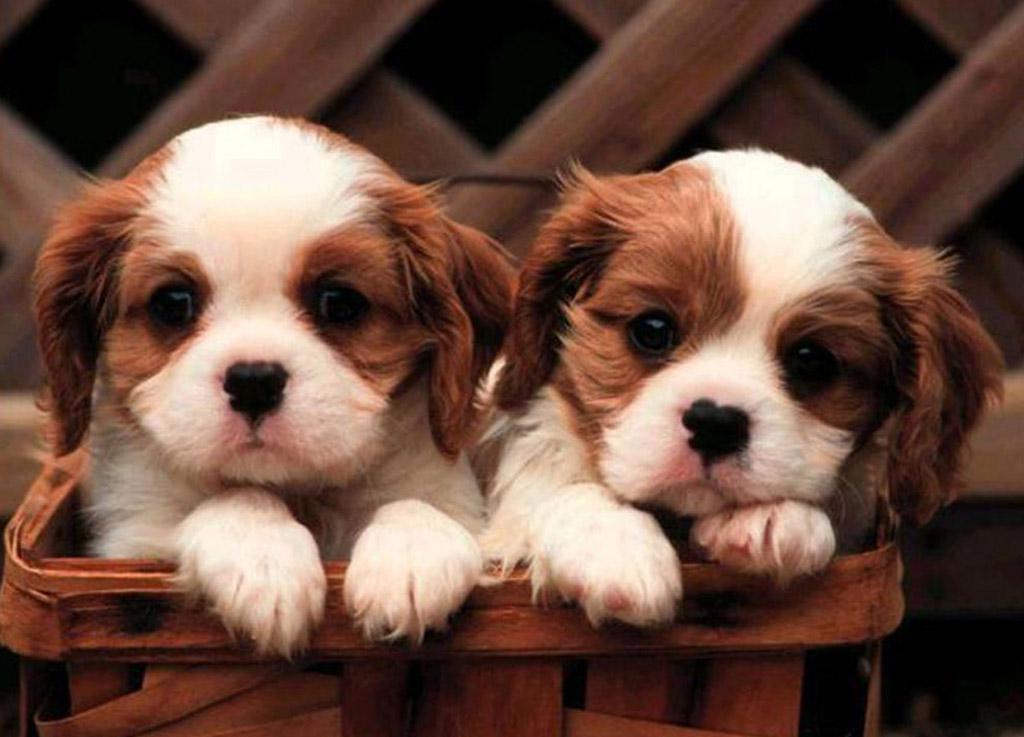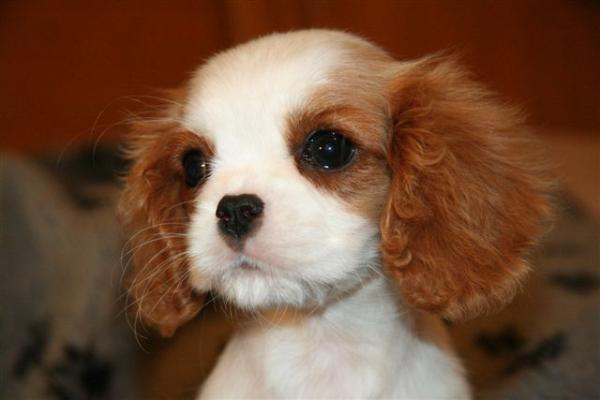The first image is the image on the left, the second image is the image on the right. For the images displayed, is the sentence "The right and left images contain the same number of puppies." factually correct? Answer yes or no. No. 